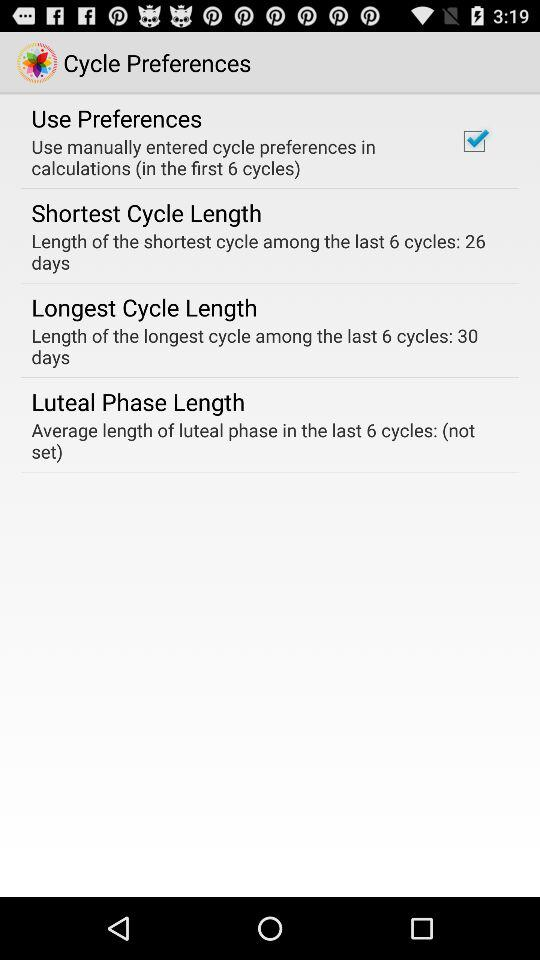How many days is the average luteal phase?
Answer the question using a single word or phrase. (not set) 